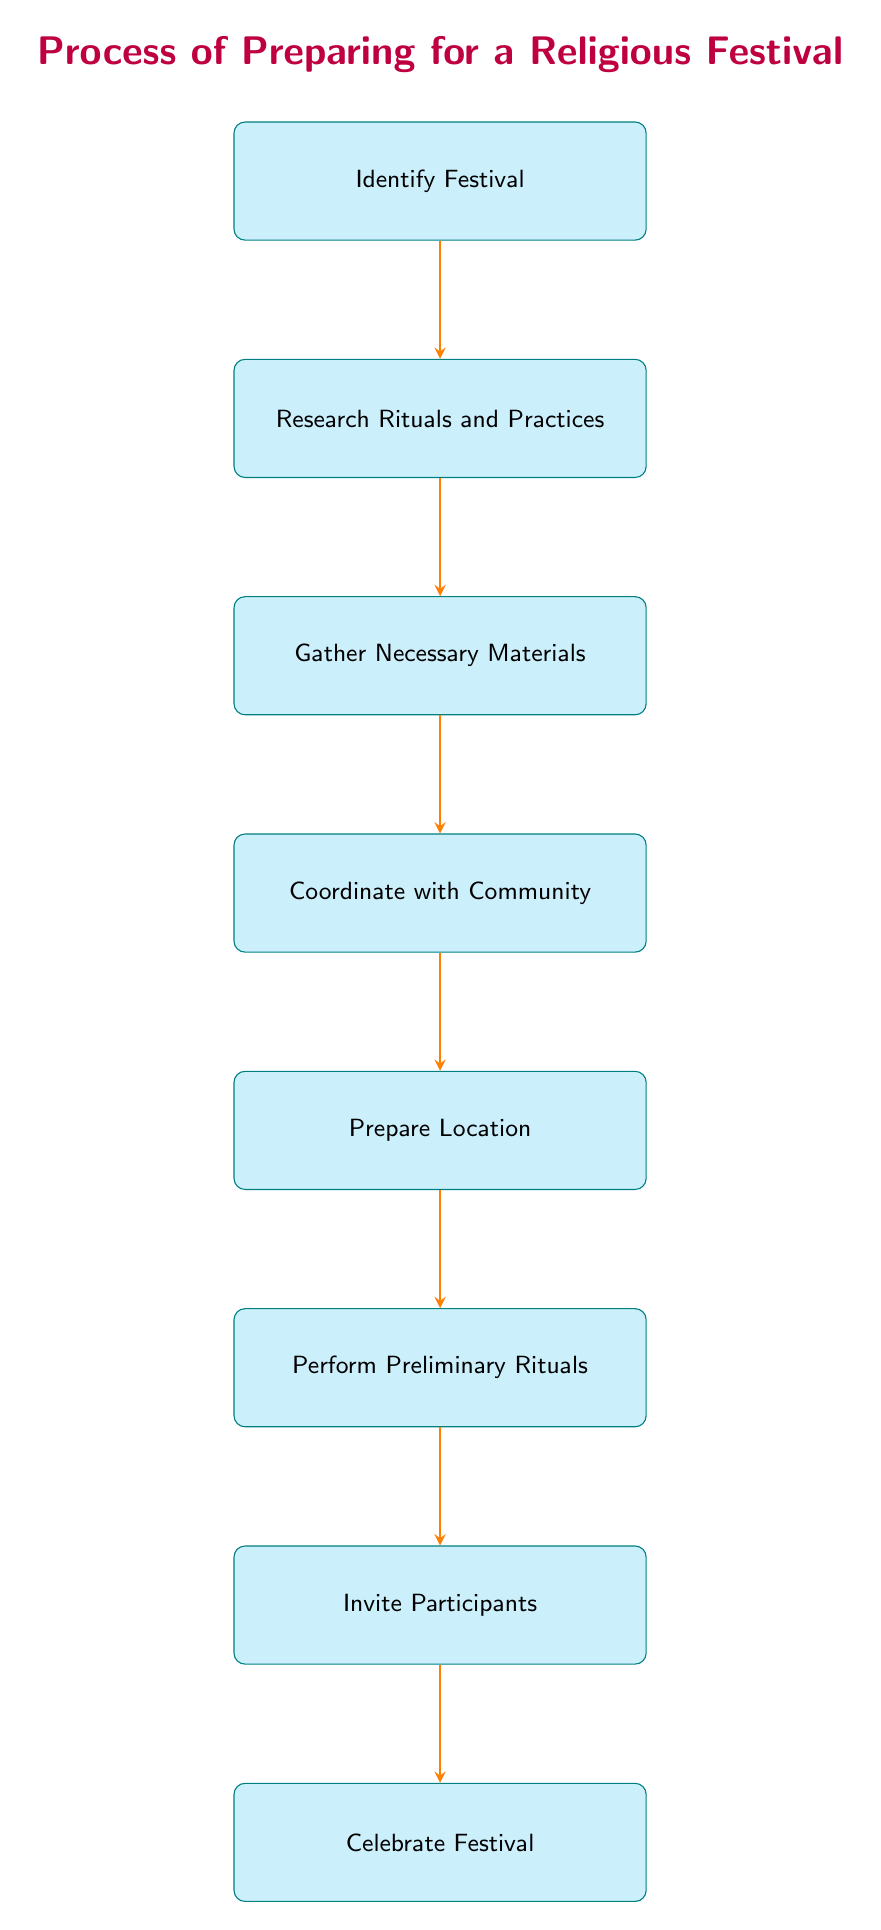What is the first step in the diagram? The first step is indicated by the top node in the flow chart, which is "Identify Festival."
Answer: Identify Festival How many total nodes are in the diagram? Counting all the boxes from top to bottom, there are eight nodes in total, representing each step in the process.
Answer: 8 What is the last step in the process? The last step in the flow is "Celebrate Festival," which is represented by the bottommost node in the diagram.
Answer: Celebrate Festival Which step follows "Gather Necessary Materials"? The arrow leading from "Gather Necessary Materials" points to the next step, which is "Coordinate with Community."
Answer: Coordinate with Community What is the relationship between "Perform Preliminary Rituals" and "Invite Participants"? "Perform Preliminary Rituals" directly precedes "Invite Participants" in the flow of the diagram, indicating that you perform preliminary rituals before inviting participants.
Answer: Directly precedes What is required before "Celebrate Festival"? Before reaching the "Celebrate Festival" node, participants must go through "Invite Participants," which is the immediate step before the celebration.
Answer: Invite Participants What step involves community engagement? The step titled "Coordinate with Community" explicitly states that it involves communication and coordination with other community members.
Answer: Coordinate with Community How many connections are made between nodes? By counting the arrows connecting each node in the flow chart, there are seven connections linking the steps together.
Answer: 7 